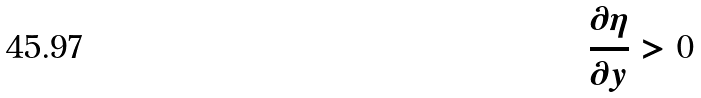Convert formula to latex. <formula><loc_0><loc_0><loc_500><loc_500>\frac { \partial \eta } { \partial y } > 0</formula> 